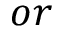Convert formula to latex. <formula><loc_0><loc_0><loc_500><loc_500>o r</formula> 